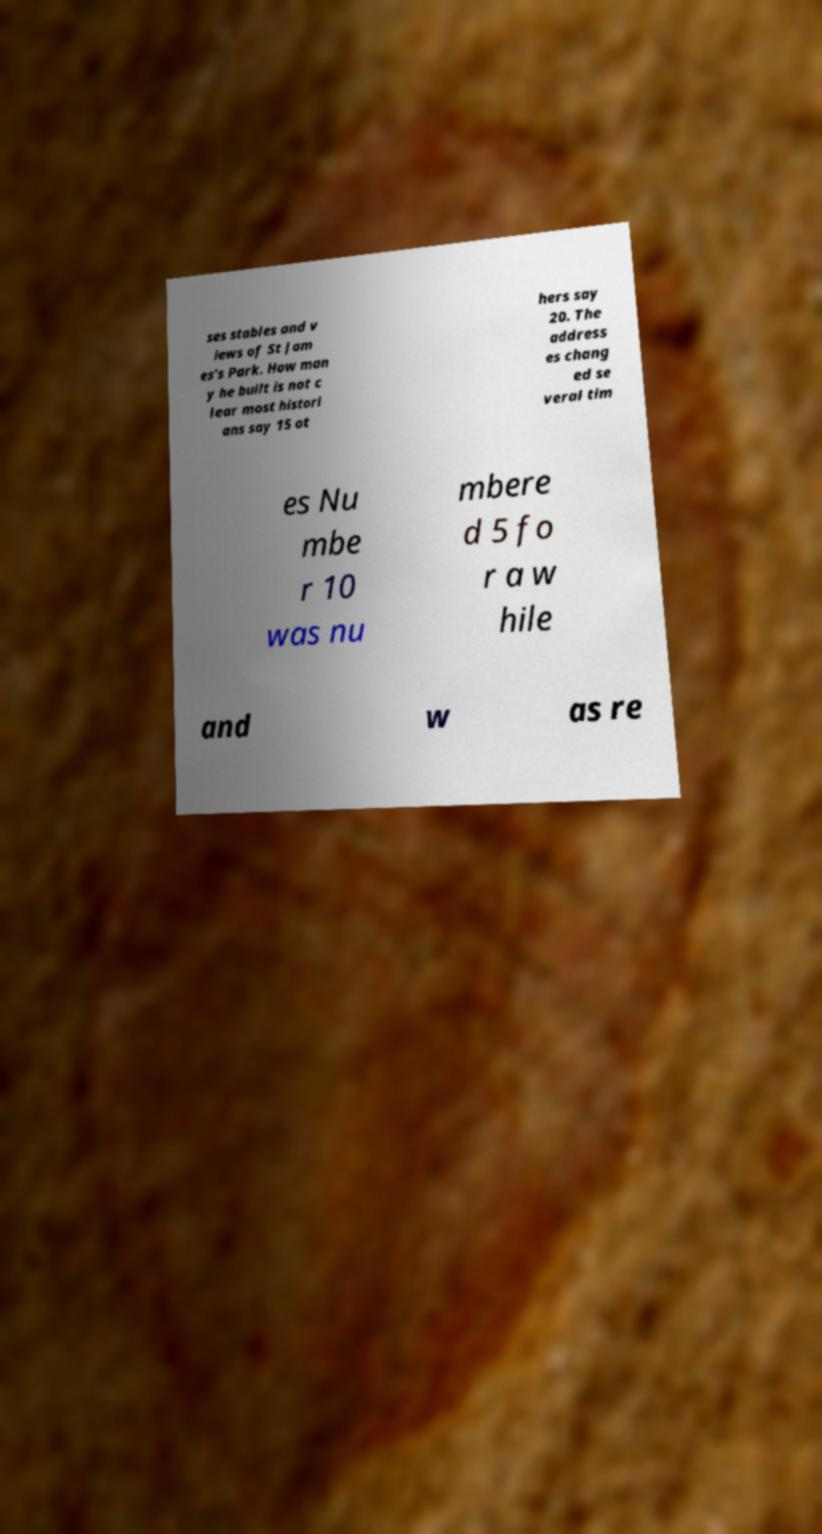Please read and relay the text visible in this image. What does it say? ses stables and v iews of St Jam es's Park. How man y he built is not c lear most histori ans say 15 ot hers say 20. The address es chang ed se veral tim es Nu mbe r 10 was nu mbere d 5 fo r a w hile and w as re 